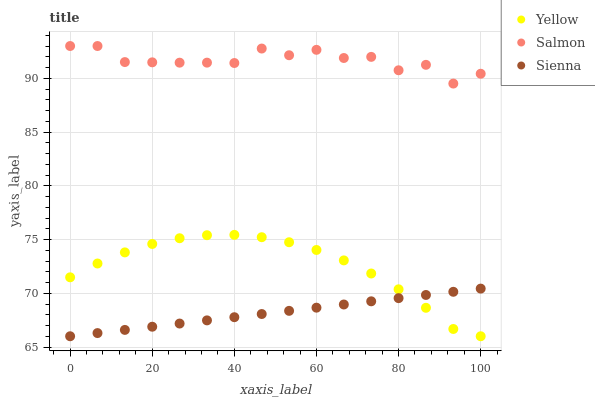Does Sienna have the minimum area under the curve?
Answer yes or no. Yes. Does Salmon have the maximum area under the curve?
Answer yes or no. Yes. Does Yellow have the minimum area under the curve?
Answer yes or no. No. Does Yellow have the maximum area under the curve?
Answer yes or no. No. Is Sienna the smoothest?
Answer yes or no. Yes. Is Salmon the roughest?
Answer yes or no. Yes. Is Yellow the smoothest?
Answer yes or no. No. Is Yellow the roughest?
Answer yes or no. No. Does Sienna have the lowest value?
Answer yes or no. Yes. Does Salmon have the lowest value?
Answer yes or no. No. Does Salmon have the highest value?
Answer yes or no. Yes. Does Yellow have the highest value?
Answer yes or no. No. Is Yellow less than Salmon?
Answer yes or no. Yes. Is Salmon greater than Sienna?
Answer yes or no. Yes. Does Yellow intersect Sienna?
Answer yes or no. Yes. Is Yellow less than Sienna?
Answer yes or no. No. Is Yellow greater than Sienna?
Answer yes or no. No. Does Yellow intersect Salmon?
Answer yes or no. No. 